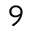Convert formula to latex. <formula><loc_0><loc_0><loc_500><loc_500>_ { 9 }</formula> 